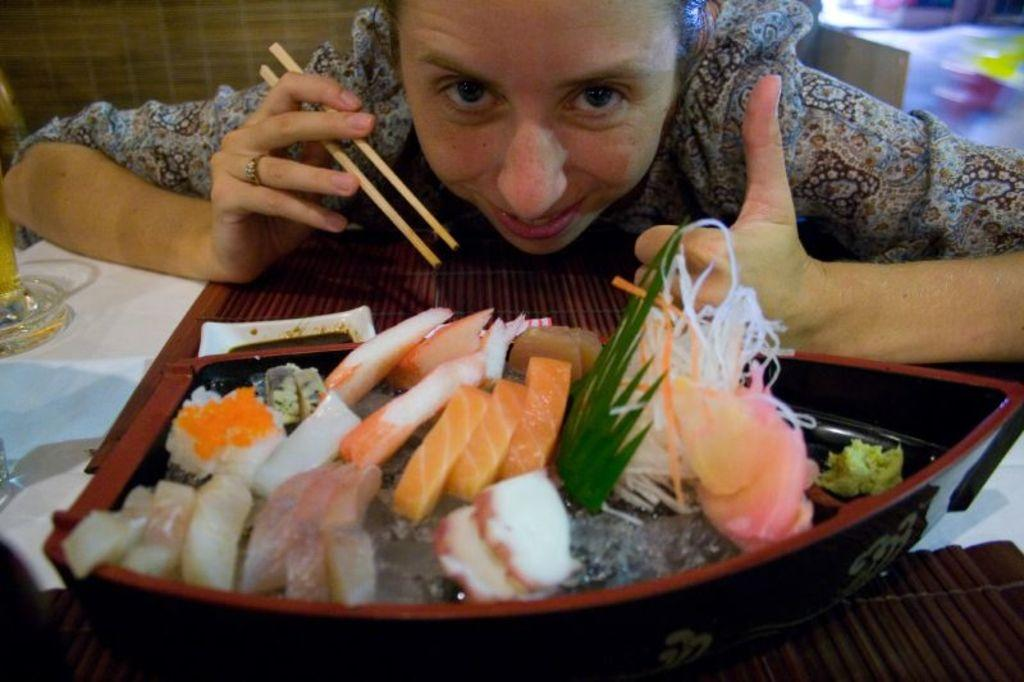Who is the main subject in the image? There is a person in the image. What is the person doing in the image? The person is sitting on a chair. Where is the chair located in relation to the table? The chair is in front of a table. What can be found on the table in the image? There is a bowl on the table. What type of hope can be seen in the image? There is no reference to hope in the image, so it is not possible to determine what type of hope might be present. 